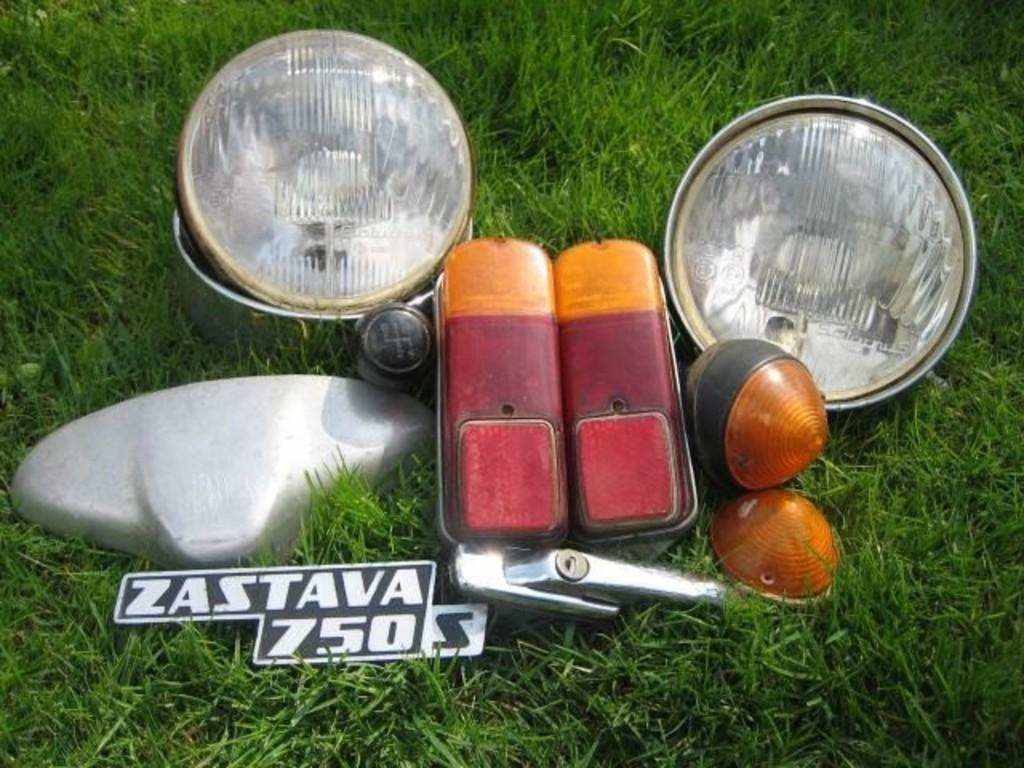What type of illumination is present in the image? There are lights in the image. What color are the silver objects in the image? The silver color objects in the image are, well, silver. What can be seen on the board in the image? The facts provided do not specify what is on the board, so we cannot answer that question definitively. What color is the grass in the image? The grass in the image is green. Can you read the title of the receipt in the image? There is no receipt present in the image, so we cannot read any titles. How many wheels can be seen on the objects in the image? There are no objects with wheels present in the image. 